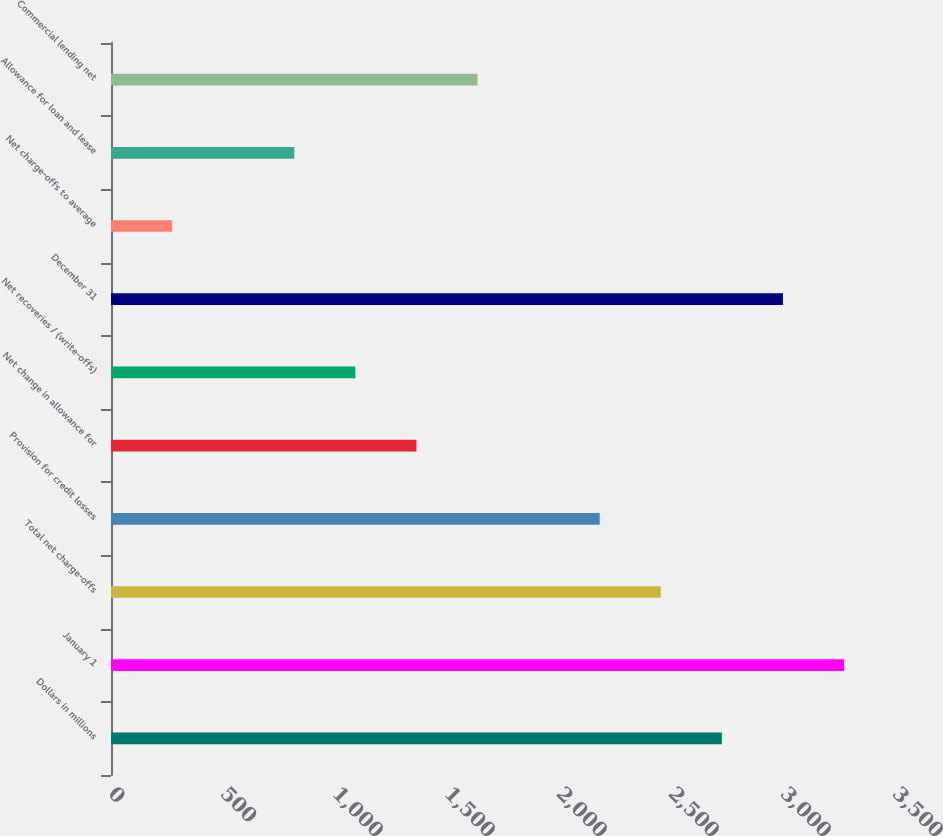Convert chart. <chart><loc_0><loc_0><loc_500><loc_500><bar_chart><fcel>Dollars in millions<fcel>January 1<fcel>Total net charge-offs<fcel>Provision for credit losses<fcel>Net change in allowance for<fcel>Net recoveries / (write-offs)<fcel>December 31<fcel>Net charge-offs to average<fcel>Allowance for loan and lease<fcel>Commercial lending net<nl><fcel>2727.04<fcel>3272.42<fcel>2454.35<fcel>2181.66<fcel>1363.59<fcel>1090.9<fcel>2999.73<fcel>272.83<fcel>818.21<fcel>1636.28<nl></chart> 